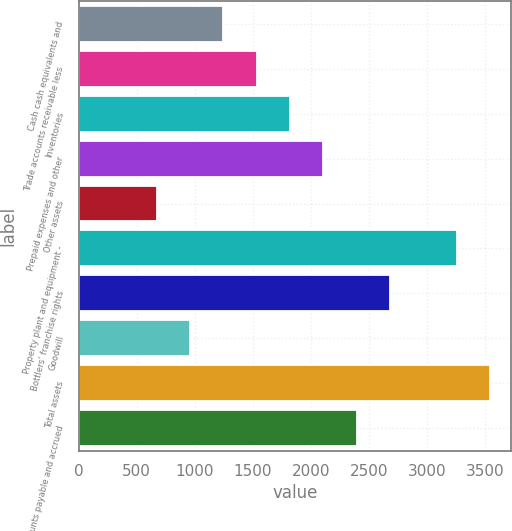Convert chart. <chart><loc_0><loc_0><loc_500><loc_500><bar_chart><fcel>Cash cash equivalents and<fcel>Trade accounts receivable less<fcel>Inventories<fcel>Prepaid expenses and other<fcel>Other assets<fcel>Property plant and equipment -<fcel>Bottlers' franchise rights<fcel>Goodwill<fcel>Total assets<fcel>Accounts payable and accrued<nl><fcel>1246.2<fcel>1534<fcel>1821.8<fcel>2109.6<fcel>670.6<fcel>3260.8<fcel>2685.2<fcel>958.4<fcel>3548.6<fcel>2397.4<nl></chart> 